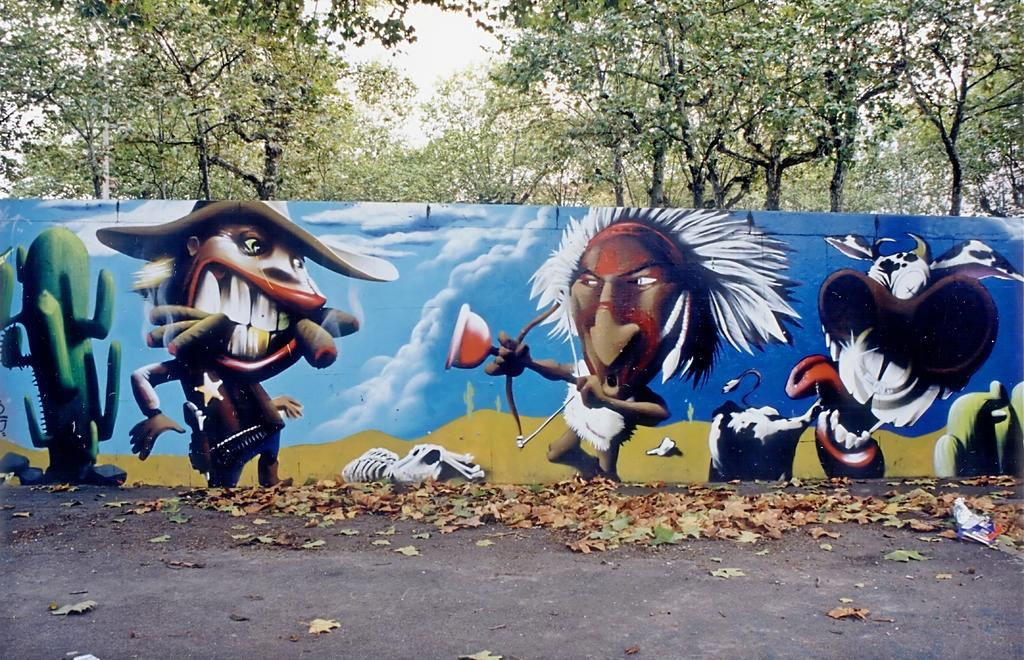What can be seen on the ground in the image? There are dried leaves on the ground in the image. What is hanging on the wall in the image? There is a painting on the wall in the image. What type of vegetation is visible in the image? There are trees visible in the image. What is visible in the background of the image? The sky is visible in the background of the image. What time is the hospital visit scheduled for in the image? There is no mention of a hospital or a scheduled visit in the image. What type of loss is depicted in the image? There is no depiction of loss in the image; it features dried leaves on the ground, a painting on the wall, trees, and the sky. 